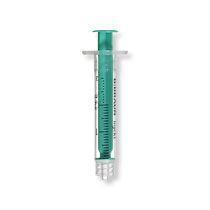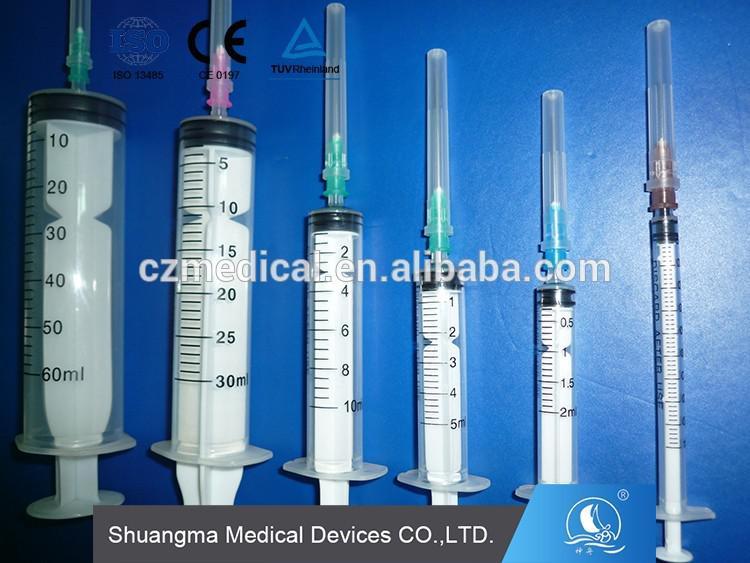The first image is the image on the left, the second image is the image on the right. For the images displayed, is the sentence "Left image shows exactly one syringe-type item, with a green plunger." factually correct? Answer yes or no. Yes. The first image is the image on the left, the second image is the image on the right. Analyze the images presented: Is the assertion "There is a single green syringe in the left image" valid? Answer yes or no. Yes. 